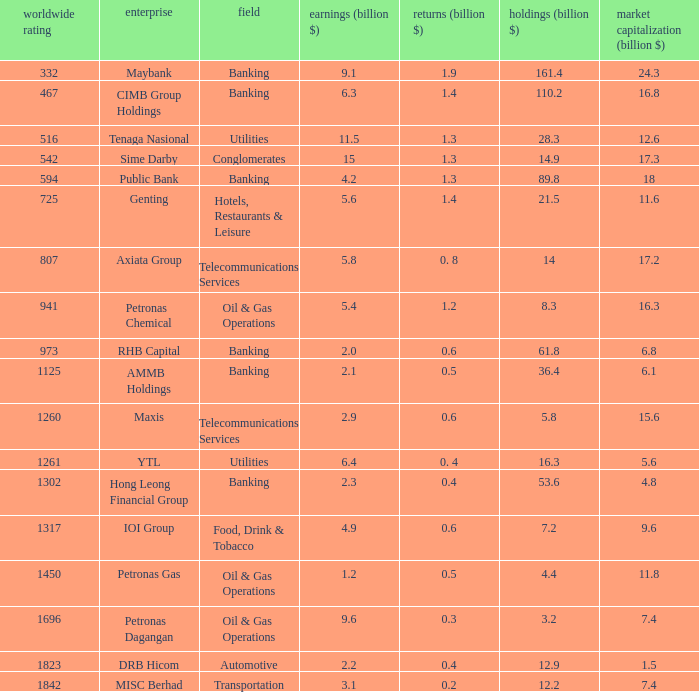Identify the sector with Banking. 